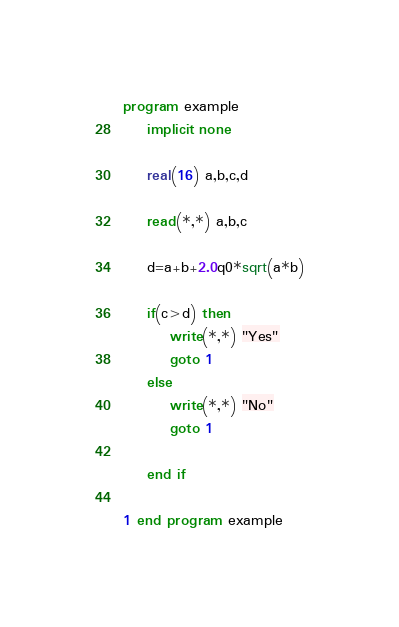<code> <loc_0><loc_0><loc_500><loc_500><_FORTRAN_>program example
	implicit none

	real(16) a,b,c,d

	read(*,*) a,b,c
    
    d=a+b+2.0q0*sqrt(a*b)
        
    if(c>d) then
    	write(*,*) "Yes"
        goto 1
    else
    	write(*,*) "No"
        goto 1
        
    end if

1 end program example</code> 